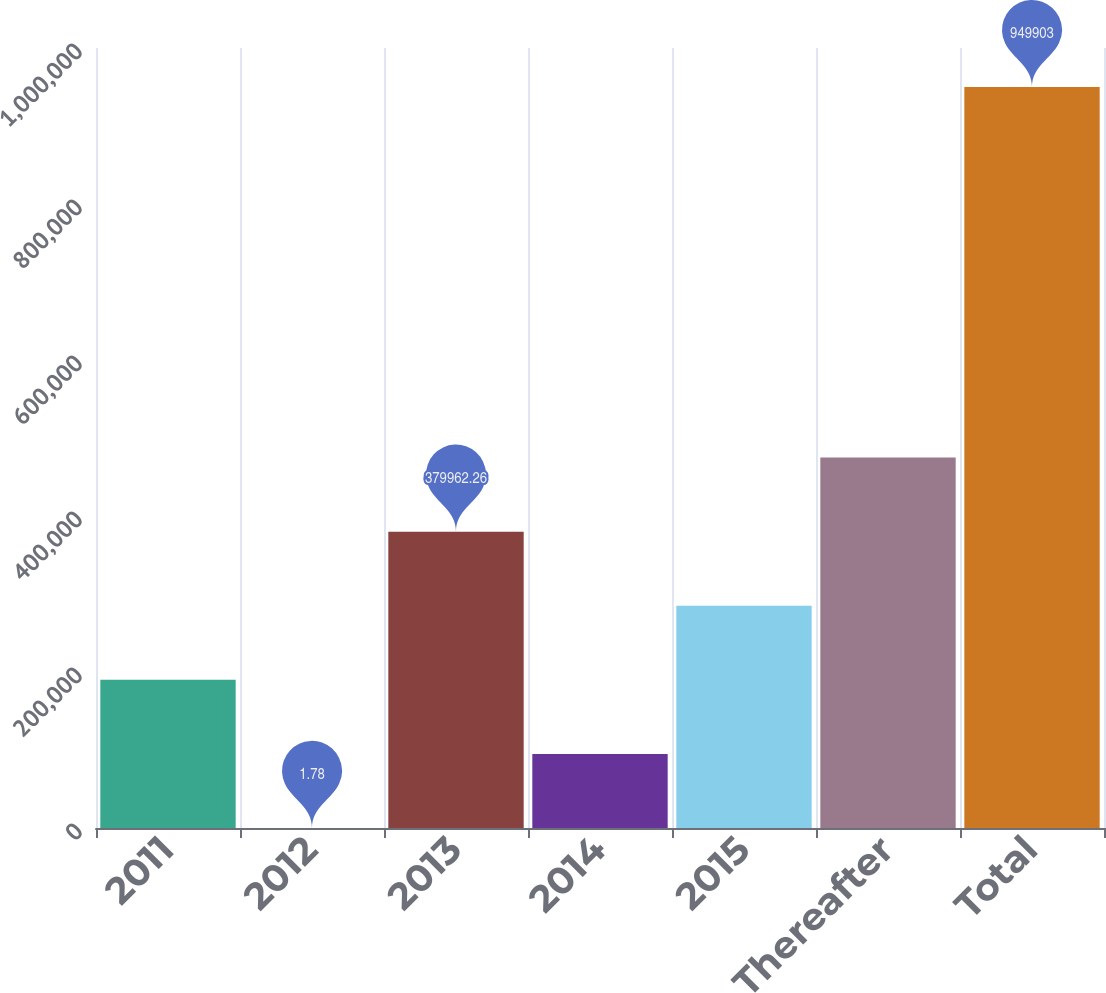<chart> <loc_0><loc_0><loc_500><loc_500><bar_chart><fcel>2011<fcel>2012<fcel>2013<fcel>2014<fcel>2015<fcel>Thereafter<fcel>Total<nl><fcel>189982<fcel>1.78<fcel>379962<fcel>94991.9<fcel>284972<fcel>474952<fcel>949903<nl></chart> 